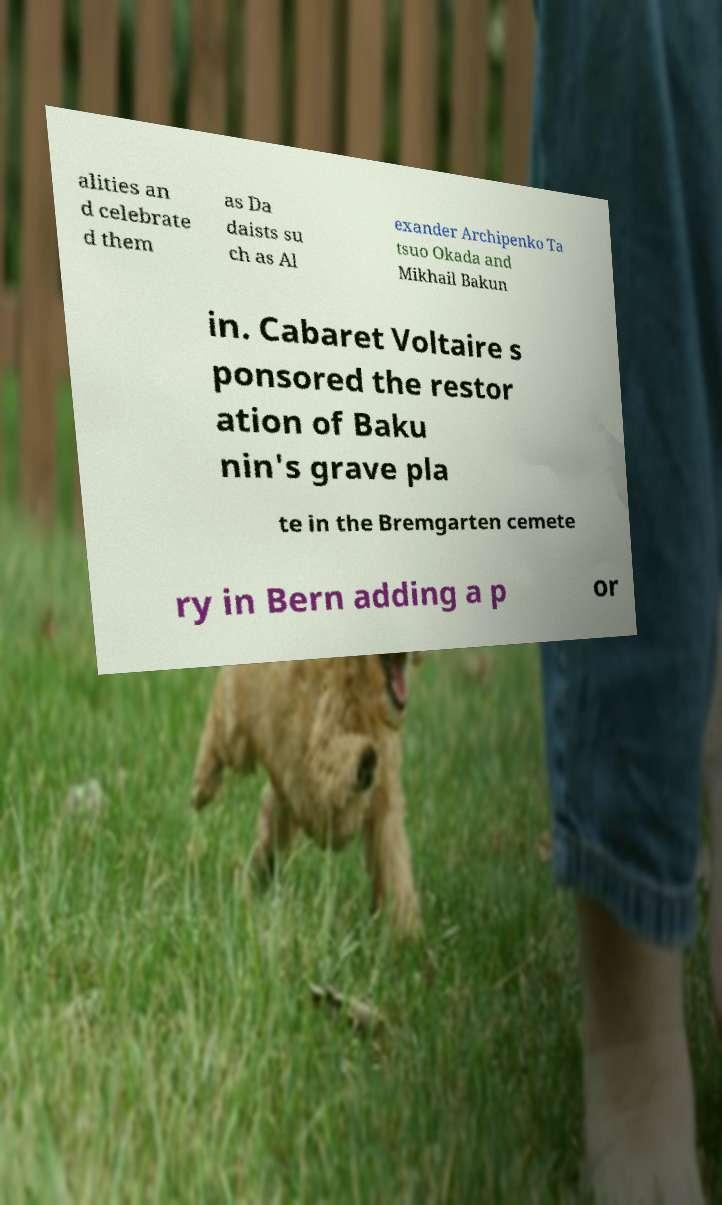Can you read and provide the text displayed in the image?This photo seems to have some interesting text. Can you extract and type it out for me? alities an d celebrate d them as Da daists su ch as Al exander Archipenko Ta tsuo Okada and Mikhail Bakun in. Cabaret Voltaire s ponsored the restor ation of Baku nin's grave pla te in the Bremgarten cemete ry in Bern adding a p or 